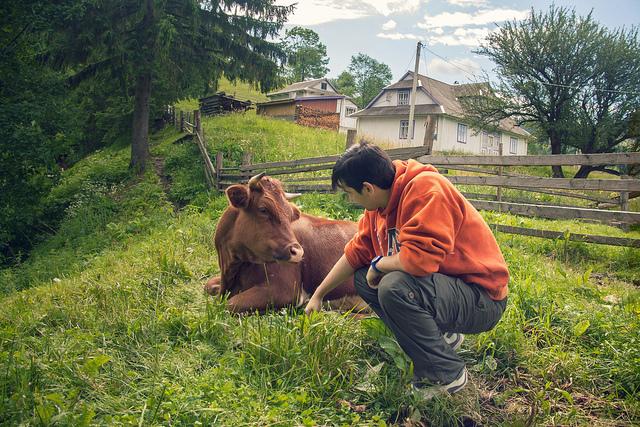What color is the sweater?
Answer briefly. Orange. Where is the house?
Answer briefly. Behind fence. What type of cow is this?
Give a very brief answer. Brown. 